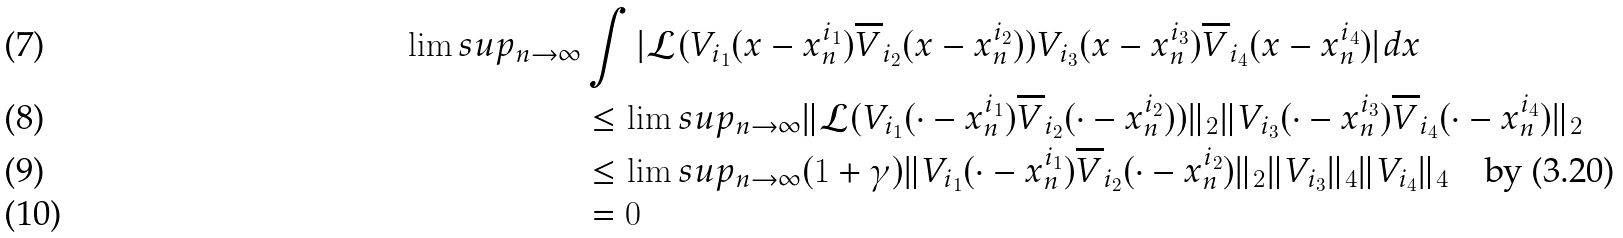<formula> <loc_0><loc_0><loc_500><loc_500>\lim s u p _ { n \rightarrow \infty } & \int | \mathcal { L } ( V _ { i _ { 1 } } ( x - x _ { n } ^ { i _ { 1 } } ) \overline { V } _ { i _ { 2 } } ( x - x _ { n } ^ { i _ { 2 } } ) ) V _ { i _ { 3 } } ( x - x _ { n } ^ { i _ { 3 } } ) \overline { V } _ { i _ { 4 } } ( x - x _ { n } ^ { i _ { 4 } } ) | d x \\ & \leq \lim s u p _ { n \rightarrow \infty } \| \mathcal { L } ( V _ { i _ { 1 } } ( \cdot - x _ { n } ^ { i _ { 1 } } ) \overline { V } _ { i _ { 2 } } ( \cdot - x _ { n } ^ { i _ { 2 } } ) ) \| _ { 2 } \| V _ { i _ { 3 } } ( \cdot - x _ { n } ^ { i _ { 3 } } ) \overline { V } _ { i _ { 4 } } ( \cdot - x _ { n } ^ { i _ { 4 } } ) \| _ { 2 } \\ & \leq \lim s u p _ { n \rightarrow \infty } ( 1 + \gamma ) \| V _ { i _ { 1 } } ( \cdot - x _ { n } ^ { i _ { 1 } } ) \overline { V } _ { i _ { 2 } } ( \cdot - x _ { n } ^ { i _ { 2 } } ) \| _ { 2 } \| V _ { i _ { 3 } } \| _ { 4 } \| V _ { i _ { 4 } } \| _ { 4 } \quad \text {by (3.20)} \\ & = 0</formula> 